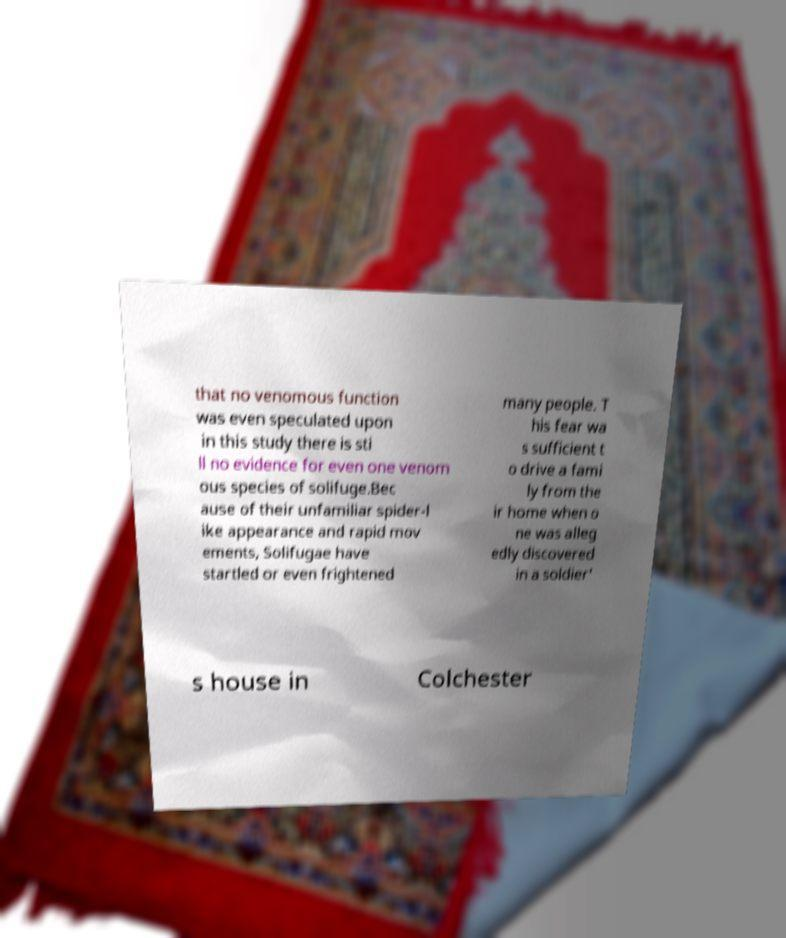Can you accurately transcribe the text from the provided image for me? that no venomous function was even speculated upon in this study there is sti ll no evidence for even one venom ous species of solifuge.Bec ause of their unfamiliar spider-l ike appearance and rapid mov ements, Solifugae have startled or even frightened many people. T his fear wa s sufficient t o drive a fami ly from the ir home when o ne was alleg edly discovered in a soldier' s house in Colchester 